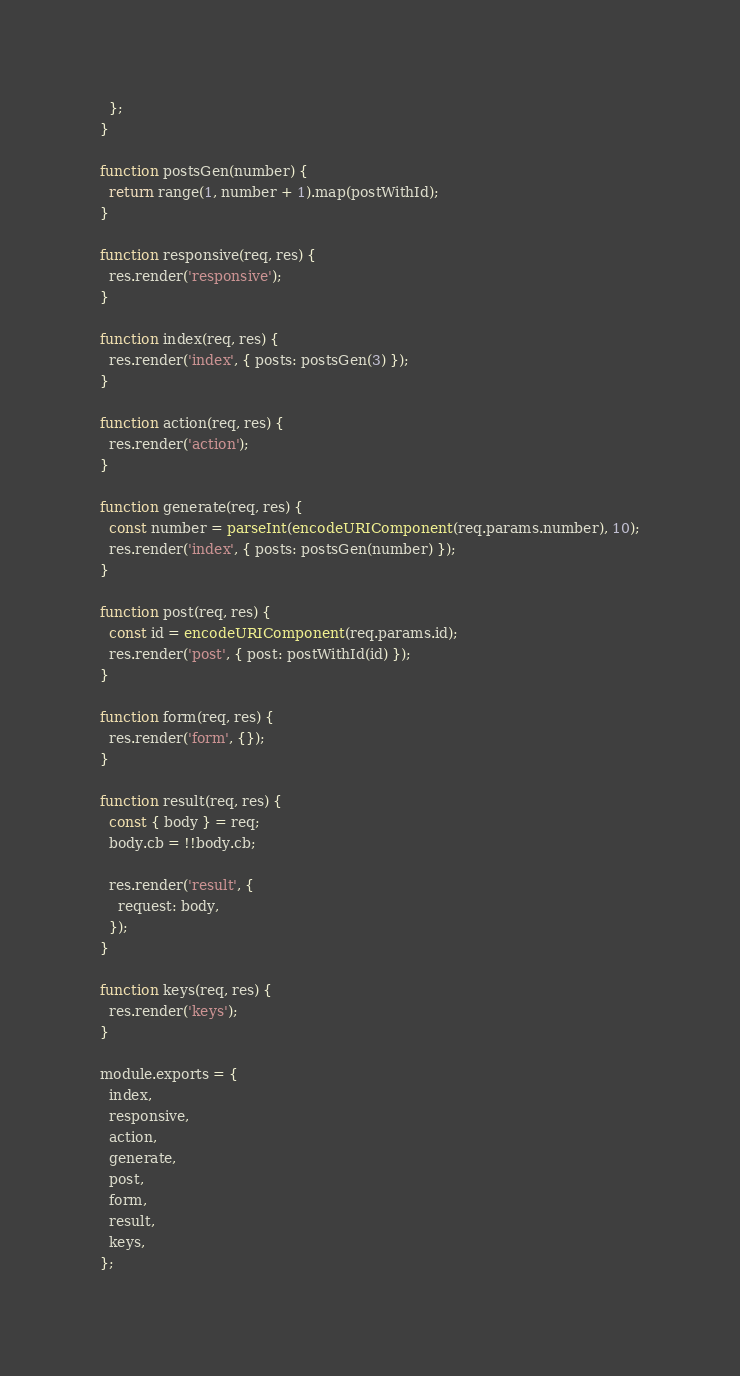<code> <loc_0><loc_0><loc_500><loc_500><_JavaScript_>  };
}

function postsGen(number) {
  return range(1, number + 1).map(postWithId);
}

function responsive(req, res) {
  res.render('responsive');
}

function index(req, res) {
  res.render('index', { posts: postsGen(3) });
}

function action(req, res) {
  res.render('action');
}

function generate(req, res) {
  const number = parseInt(encodeURIComponent(req.params.number), 10);
  res.render('index', { posts: postsGen(number) });
}

function post(req, res) {
  const id = encodeURIComponent(req.params.id);
  res.render('post', { post: postWithId(id) });
}

function form(req, res) {
  res.render('form', {});
}

function result(req, res) {
  const { body } = req;
  body.cb = !!body.cb;

  res.render('result', {
    request: body,
  });
}

function keys(req, res) {
  res.render('keys');
}

module.exports = {
  index,
  responsive,
  action,
  generate,
  post,
  form,
  result,
  keys,
};
</code> 